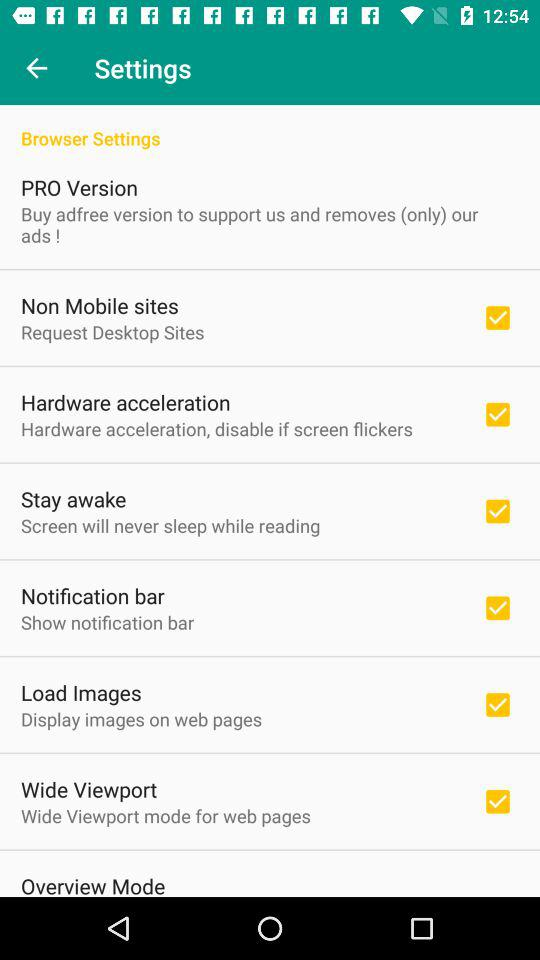What is the status of the stay awake option? The status is on. 